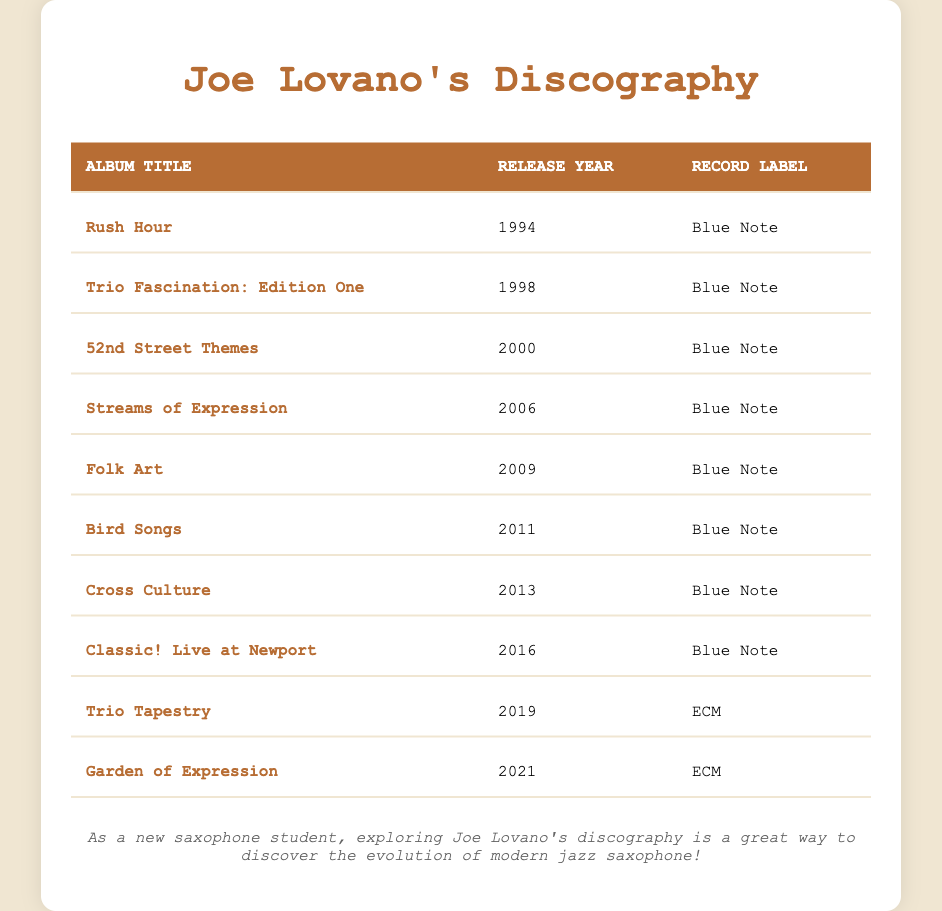What was the first album released by Joe Lovano? Looking at the "Release Year" column, the first entry is "Rush Hour," which was released in 1994.
Answer: Rush Hour How many albums did Joe Lovano release between 2000 and 2010? From the table, the albums released during this period are "52nd Street Themes" (2000), "Streams of Expression" (2006), "Folk Art" (2009), and "Bird Songs" (2011). Counting these, there are four albums.
Answer: 4 What is the record label for "Trio Tapestry"? The table shows that "Trio Tapestry" was released in 2019 under the record label "ECM."
Answer: ECM Is "Garden of Expression" the last album listed in the table? The last entry in the table is indeed "Garden of Expression," released in 2021, confirming it is the most recent album.
Answer: Yes Which record label has Joe Lovano released the most albums under? By reviewing the table, we can see that the "Blue Note" label appears for the albums "Rush Hour," "Trio Fascination: Edition One," "52nd Street Themes," "Streams of Expression," "Folk Art," "Bird Songs," "Cross Culture," and "Classic! Live at Newport." That's a total of eight albums, while "ECM" has two. This confirms "Blue Note" has the most albums.
Answer: Blue Note What is the median release year of Joe Lovano’s albums? To find the median release year, we need to list the release years in order: 1994, 1998, 2000, 2006, 2009, 2011, 2013, 2016, 2019, and 2021. With 10 values, the median is the average of the 5th and 6th values: (2009 + 2011) / 2 = 2010.
Answer: 2010 How many years separate the release of "Folk Art" and "Cross Culture"? "Folk Art" was released in 2009 and "Cross Culture" in 2013. The difference in years is calculated as 2013 - 2009 = 4 years.
Answer: 4 years Have all of Joe Lovano's albums been released under just two record labels? From the table, we see "Blue Note" has eight entries, and "ECM" has two entries. Therefore, it confirms that all of them are under these two labels.
Answer: Yes 